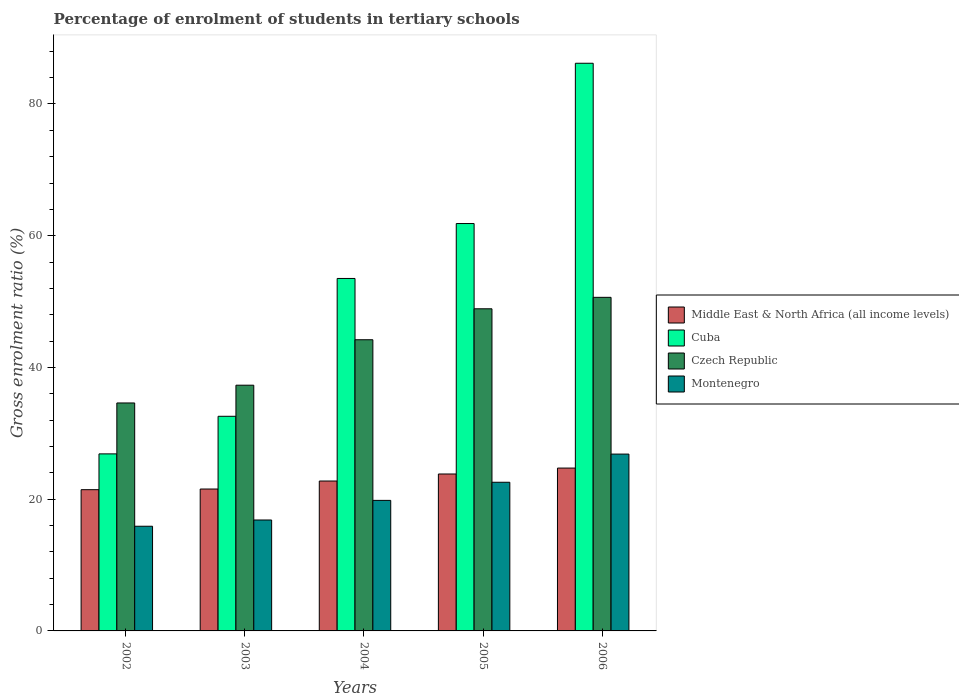How many different coloured bars are there?
Your answer should be very brief. 4. Are the number of bars per tick equal to the number of legend labels?
Provide a succinct answer. Yes. How many bars are there on the 2nd tick from the left?
Provide a succinct answer. 4. How many bars are there on the 2nd tick from the right?
Provide a succinct answer. 4. In how many cases, is the number of bars for a given year not equal to the number of legend labels?
Make the answer very short. 0. What is the percentage of students enrolled in tertiary schools in Montenegro in 2005?
Provide a succinct answer. 22.57. Across all years, what is the maximum percentage of students enrolled in tertiary schools in Czech Republic?
Provide a short and direct response. 50.65. Across all years, what is the minimum percentage of students enrolled in tertiary schools in Cuba?
Provide a short and direct response. 26.88. In which year was the percentage of students enrolled in tertiary schools in Middle East & North Africa (all income levels) maximum?
Offer a very short reply. 2006. What is the total percentage of students enrolled in tertiary schools in Middle East & North Africa (all income levels) in the graph?
Offer a very short reply. 114.3. What is the difference between the percentage of students enrolled in tertiary schools in Cuba in 2003 and that in 2005?
Your answer should be very brief. -29.26. What is the difference between the percentage of students enrolled in tertiary schools in Czech Republic in 2005 and the percentage of students enrolled in tertiary schools in Middle East & North Africa (all income levels) in 2006?
Your response must be concise. 24.18. What is the average percentage of students enrolled in tertiary schools in Czech Republic per year?
Give a very brief answer. 43.14. In the year 2002, what is the difference between the percentage of students enrolled in tertiary schools in Cuba and percentage of students enrolled in tertiary schools in Montenegro?
Offer a terse response. 10.98. In how many years, is the percentage of students enrolled in tertiary schools in Montenegro greater than 76 %?
Offer a very short reply. 0. What is the ratio of the percentage of students enrolled in tertiary schools in Middle East & North Africa (all income levels) in 2002 to that in 2006?
Offer a terse response. 0.87. What is the difference between the highest and the second highest percentage of students enrolled in tertiary schools in Czech Republic?
Give a very brief answer. 1.74. What is the difference between the highest and the lowest percentage of students enrolled in tertiary schools in Cuba?
Your answer should be compact. 59.31. What does the 1st bar from the left in 2006 represents?
Make the answer very short. Middle East & North Africa (all income levels). What does the 4th bar from the right in 2004 represents?
Make the answer very short. Middle East & North Africa (all income levels). How many bars are there?
Give a very brief answer. 20. How many years are there in the graph?
Give a very brief answer. 5. Are the values on the major ticks of Y-axis written in scientific E-notation?
Provide a short and direct response. No. Does the graph contain any zero values?
Give a very brief answer. No. Does the graph contain grids?
Keep it short and to the point. No. How are the legend labels stacked?
Offer a very short reply. Vertical. What is the title of the graph?
Make the answer very short. Percentage of enrolment of students in tertiary schools. What is the Gross enrolment ratio (%) in Middle East & North Africa (all income levels) in 2002?
Your answer should be very brief. 21.44. What is the Gross enrolment ratio (%) of Cuba in 2002?
Make the answer very short. 26.88. What is the Gross enrolment ratio (%) in Czech Republic in 2002?
Your answer should be very brief. 34.61. What is the Gross enrolment ratio (%) in Montenegro in 2002?
Offer a very short reply. 15.89. What is the Gross enrolment ratio (%) in Middle East & North Africa (all income levels) in 2003?
Offer a terse response. 21.54. What is the Gross enrolment ratio (%) in Cuba in 2003?
Provide a succinct answer. 32.59. What is the Gross enrolment ratio (%) of Czech Republic in 2003?
Provide a short and direct response. 37.31. What is the Gross enrolment ratio (%) in Montenegro in 2003?
Your answer should be very brief. 16.84. What is the Gross enrolment ratio (%) of Middle East & North Africa (all income levels) in 2004?
Provide a succinct answer. 22.76. What is the Gross enrolment ratio (%) of Cuba in 2004?
Give a very brief answer. 53.51. What is the Gross enrolment ratio (%) of Czech Republic in 2004?
Offer a terse response. 44.21. What is the Gross enrolment ratio (%) in Montenegro in 2004?
Your answer should be very brief. 19.82. What is the Gross enrolment ratio (%) in Middle East & North Africa (all income levels) in 2005?
Give a very brief answer. 23.83. What is the Gross enrolment ratio (%) of Cuba in 2005?
Your response must be concise. 61.85. What is the Gross enrolment ratio (%) in Czech Republic in 2005?
Provide a short and direct response. 48.91. What is the Gross enrolment ratio (%) of Montenegro in 2005?
Your response must be concise. 22.57. What is the Gross enrolment ratio (%) of Middle East & North Africa (all income levels) in 2006?
Offer a very short reply. 24.73. What is the Gross enrolment ratio (%) of Cuba in 2006?
Offer a very short reply. 86.19. What is the Gross enrolment ratio (%) in Czech Republic in 2006?
Offer a terse response. 50.65. What is the Gross enrolment ratio (%) in Montenegro in 2006?
Keep it short and to the point. 26.85. Across all years, what is the maximum Gross enrolment ratio (%) in Middle East & North Africa (all income levels)?
Your answer should be very brief. 24.73. Across all years, what is the maximum Gross enrolment ratio (%) in Cuba?
Your answer should be very brief. 86.19. Across all years, what is the maximum Gross enrolment ratio (%) in Czech Republic?
Ensure brevity in your answer.  50.65. Across all years, what is the maximum Gross enrolment ratio (%) in Montenegro?
Provide a short and direct response. 26.85. Across all years, what is the minimum Gross enrolment ratio (%) of Middle East & North Africa (all income levels)?
Your answer should be compact. 21.44. Across all years, what is the minimum Gross enrolment ratio (%) in Cuba?
Your answer should be compact. 26.88. Across all years, what is the minimum Gross enrolment ratio (%) in Czech Republic?
Your answer should be compact. 34.61. Across all years, what is the minimum Gross enrolment ratio (%) in Montenegro?
Offer a terse response. 15.89. What is the total Gross enrolment ratio (%) in Middle East & North Africa (all income levels) in the graph?
Offer a very short reply. 114.3. What is the total Gross enrolment ratio (%) of Cuba in the graph?
Your response must be concise. 261.01. What is the total Gross enrolment ratio (%) of Czech Republic in the graph?
Give a very brief answer. 215.68. What is the total Gross enrolment ratio (%) in Montenegro in the graph?
Your response must be concise. 101.97. What is the difference between the Gross enrolment ratio (%) of Middle East & North Africa (all income levels) in 2002 and that in 2003?
Your answer should be very brief. -0.1. What is the difference between the Gross enrolment ratio (%) in Cuba in 2002 and that in 2003?
Provide a short and direct response. -5.71. What is the difference between the Gross enrolment ratio (%) of Czech Republic in 2002 and that in 2003?
Your answer should be compact. -2.7. What is the difference between the Gross enrolment ratio (%) in Montenegro in 2002 and that in 2003?
Make the answer very short. -0.95. What is the difference between the Gross enrolment ratio (%) of Middle East & North Africa (all income levels) in 2002 and that in 2004?
Provide a short and direct response. -1.31. What is the difference between the Gross enrolment ratio (%) of Cuba in 2002 and that in 2004?
Offer a terse response. -26.63. What is the difference between the Gross enrolment ratio (%) of Czech Republic in 2002 and that in 2004?
Offer a terse response. -9.6. What is the difference between the Gross enrolment ratio (%) in Montenegro in 2002 and that in 2004?
Your response must be concise. -3.92. What is the difference between the Gross enrolment ratio (%) of Middle East & North Africa (all income levels) in 2002 and that in 2005?
Keep it short and to the point. -2.38. What is the difference between the Gross enrolment ratio (%) in Cuba in 2002 and that in 2005?
Make the answer very short. -34.97. What is the difference between the Gross enrolment ratio (%) of Czech Republic in 2002 and that in 2005?
Your answer should be very brief. -14.3. What is the difference between the Gross enrolment ratio (%) of Montenegro in 2002 and that in 2005?
Your response must be concise. -6.68. What is the difference between the Gross enrolment ratio (%) of Middle East & North Africa (all income levels) in 2002 and that in 2006?
Keep it short and to the point. -3.28. What is the difference between the Gross enrolment ratio (%) in Cuba in 2002 and that in 2006?
Your response must be concise. -59.31. What is the difference between the Gross enrolment ratio (%) in Czech Republic in 2002 and that in 2006?
Ensure brevity in your answer.  -16.04. What is the difference between the Gross enrolment ratio (%) of Montenegro in 2002 and that in 2006?
Your response must be concise. -10.95. What is the difference between the Gross enrolment ratio (%) in Middle East & North Africa (all income levels) in 2003 and that in 2004?
Your response must be concise. -1.21. What is the difference between the Gross enrolment ratio (%) of Cuba in 2003 and that in 2004?
Offer a terse response. -20.93. What is the difference between the Gross enrolment ratio (%) in Czech Republic in 2003 and that in 2004?
Offer a terse response. -6.9. What is the difference between the Gross enrolment ratio (%) in Montenegro in 2003 and that in 2004?
Your answer should be compact. -2.98. What is the difference between the Gross enrolment ratio (%) in Middle East & North Africa (all income levels) in 2003 and that in 2005?
Ensure brevity in your answer.  -2.28. What is the difference between the Gross enrolment ratio (%) in Cuba in 2003 and that in 2005?
Your response must be concise. -29.26. What is the difference between the Gross enrolment ratio (%) of Czech Republic in 2003 and that in 2005?
Your answer should be compact. -11.6. What is the difference between the Gross enrolment ratio (%) in Montenegro in 2003 and that in 2005?
Ensure brevity in your answer.  -5.73. What is the difference between the Gross enrolment ratio (%) in Middle East & North Africa (all income levels) in 2003 and that in 2006?
Your response must be concise. -3.18. What is the difference between the Gross enrolment ratio (%) in Cuba in 2003 and that in 2006?
Offer a very short reply. -53.6. What is the difference between the Gross enrolment ratio (%) in Czech Republic in 2003 and that in 2006?
Give a very brief answer. -13.34. What is the difference between the Gross enrolment ratio (%) of Montenegro in 2003 and that in 2006?
Offer a terse response. -10.01. What is the difference between the Gross enrolment ratio (%) in Middle East & North Africa (all income levels) in 2004 and that in 2005?
Your response must be concise. -1.07. What is the difference between the Gross enrolment ratio (%) of Cuba in 2004 and that in 2005?
Your response must be concise. -8.34. What is the difference between the Gross enrolment ratio (%) of Czech Republic in 2004 and that in 2005?
Offer a terse response. -4.7. What is the difference between the Gross enrolment ratio (%) of Montenegro in 2004 and that in 2005?
Offer a very short reply. -2.75. What is the difference between the Gross enrolment ratio (%) of Middle East & North Africa (all income levels) in 2004 and that in 2006?
Your answer should be very brief. -1.97. What is the difference between the Gross enrolment ratio (%) in Cuba in 2004 and that in 2006?
Ensure brevity in your answer.  -32.67. What is the difference between the Gross enrolment ratio (%) in Czech Republic in 2004 and that in 2006?
Keep it short and to the point. -6.44. What is the difference between the Gross enrolment ratio (%) in Montenegro in 2004 and that in 2006?
Keep it short and to the point. -7.03. What is the difference between the Gross enrolment ratio (%) of Middle East & North Africa (all income levels) in 2005 and that in 2006?
Give a very brief answer. -0.9. What is the difference between the Gross enrolment ratio (%) of Cuba in 2005 and that in 2006?
Provide a succinct answer. -24.33. What is the difference between the Gross enrolment ratio (%) of Czech Republic in 2005 and that in 2006?
Your answer should be very brief. -1.74. What is the difference between the Gross enrolment ratio (%) in Montenegro in 2005 and that in 2006?
Your answer should be compact. -4.28. What is the difference between the Gross enrolment ratio (%) in Middle East & North Africa (all income levels) in 2002 and the Gross enrolment ratio (%) in Cuba in 2003?
Offer a terse response. -11.14. What is the difference between the Gross enrolment ratio (%) in Middle East & North Africa (all income levels) in 2002 and the Gross enrolment ratio (%) in Czech Republic in 2003?
Offer a very short reply. -15.86. What is the difference between the Gross enrolment ratio (%) in Middle East & North Africa (all income levels) in 2002 and the Gross enrolment ratio (%) in Montenegro in 2003?
Your response must be concise. 4.6. What is the difference between the Gross enrolment ratio (%) of Cuba in 2002 and the Gross enrolment ratio (%) of Czech Republic in 2003?
Ensure brevity in your answer.  -10.43. What is the difference between the Gross enrolment ratio (%) in Cuba in 2002 and the Gross enrolment ratio (%) in Montenegro in 2003?
Keep it short and to the point. 10.04. What is the difference between the Gross enrolment ratio (%) in Czech Republic in 2002 and the Gross enrolment ratio (%) in Montenegro in 2003?
Your answer should be compact. 17.77. What is the difference between the Gross enrolment ratio (%) of Middle East & North Africa (all income levels) in 2002 and the Gross enrolment ratio (%) of Cuba in 2004?
Provide a succinct answer. -32.07. What is the difference between the Gross enrolment ratio (%) of Middle East & North Africa (all income levels) in 2002 and the Gross enrolment ratio (%) of Czech Republic in 2004?
Your response must be concise. -22.76. What is the difference between the Gross enrolment ratio (%) in Middle East & North Africa (all income levels) in 2002 and the Gross enrolment ratio (%) in Montenegro in 2004?
Your answer should be very brief. 1.62. What is the difference between the Gross enrolment ratio (%) of Cuba in 2002 and the Gross enrolment ratio (%) of Czech Republic in 2004?
Offer a very short reply. -17.33. What is the difference between the Gross enrolment ratio (%) of Cuba in 2002 and the Gross enrolment ratio (%) of Montenegro in 2004?
Make the answer very short. 7.06. What is the difference between the Gross enrolment ratio (%) of Czech Republic in 2002 and the Gross enrolment ratio (%) of Montenegro in 2004?
Offer a very short reply. 14.79. What is the difference between the Gross enrolment ratio (%) of Middle East & North Africa (all income levels) in 2002 and the Gross enrolment ratio (%) of Cuba in 2005?
Your answer should be compact. -40.41. What is the difference between the Gross enrolment ratio (%) in Middle East & North Africa (all income levels) in 2002 and the Gross enrolment ratio (%) in Czech Republic in 2005?
Make the answer very short. -27.46. What is the difference between the Gross enrolment ratio (%) of Middle East & North Africa (all income levels) in 2002 and the Gross enrolment ratio (%) of Montenegro in 2005?
Provide a short and direct response. -1.13. What is the difference between the Gross enrolment ratio (%) in Cuba in 2002 and the Gross enrolment ratio (%) in Czech Republic in 2005?
Ensure brevity in your answer.  -22.03. What is the difference between the Gross enrolment ratio (%) in Cuba in 2002 and the Gross enrolment ratio (%) in Montenegro in 2005?
Provide a short and direct response. 4.31. What is the difference between the Gross enrolment ratio (%) in Czech Republic in 2002 and the Gross enrolment ratio (%) in Montenegro in 2005?
Your answer should be very brief. 12.04. What is the difference between the Gross enrolment ratio (%) of Middle East & North Africa (all income levels) in 2002 and the Gross enrolment ratio (%) of Cuba in 2006?
Keep it short and to the point. -64.74. What is the difference between the Gross enrolment ratio (%) of Middle East & North Africa (all income levels) in 2002 and the Gross enrolment ratio (%) of Czech Republic in 2006?
Provide a short and direct response. -29.2. What is the difference between the Gross enrolment ratio (%) in Middle East & North Africa (all income levels) in 2002 and the Gross enrolment ratio (%) in Montenegro in 2006?
Ensure brevity in your answer.  -5.4. What is the difference between the Gross enrolment ratio (%) in Cuba in 2002 and the Gross enrolment ratio (%) in Czech Republic in 2006?
Make the answer very short. -23.77. What is the difference between the Gross enrolment ratio (%) of Cuba in 2002 and the Gross enrolment ratio (%) of Montenegro in 2006?
Your answer should be compact. 0.03. What is the difference between the Gross enrolment ratio (%) of Czech Republic in 2002 and the Gross enrolment ratio (%) of Montenegro in 2006?
Make the answer very short. 7.76. What is the difference between the Gross enrolment ratio (%) in Middle East & North Africa (all income levels) in 2003 and the Gross enrolment ratio (%) in Cuba in 2004?
Your answer should be compact. -31.97. What is the difference between the Gross enrolment ratio (%) of Middle East & North Africa (all income levels) in 2003 and the Gross enrolment ratio (%) of Czech Republic in 2004?
Your response must be concise. -22.66. What is the difference between the Gross enrolment ratio (%) of Middle East & North Africa (all income levels) in 2003 and the Gross enrolment ratio (%) of Montenegro in 2004?
Your response must be concise. 1.73. What is the difference between the Gross enrolment ratio (%) in Cuba in 2003 and the Gross enrolment ratio (%) in Czech Republic in 2004?
Give a very brief answer. -11.62. What is the difference between the Gross enrolment ratio (%) of Cuba in 2003 and the Gross enrolment ratio (%) of Montenegro in 2004?
Your answer should be compact. 12.77. What is the difference between the Gross enrolment ratio (%) in Czech Republic in 2003 and the Gross enrolment ratio (%) in Montenegro in 2004?
Offer a terse response. 17.49. What is the difference between the Gross enrolment ratio (%) of Middle East & North Africa (all income levels) in 2003 and the Gross enrolment ratio (%) of Cuba in 2005?
Your response must be concise. -40.31. What is the difference between the Gross enrolment ratio (%) in Middle East & North Africa (all income levels) in 2003 and the Gross enrolment ratio (%) in Czech Republic in 2005?
Your answer should be compact. -27.36. What is the difference between the Gross enrolment ratio (%) in Middle East & North Africa (all income levels) in 2003 and the Gross enrolment ratio (%) in Montenegro in 2005?
Provide a short and direct response. -1.03. What is the difference between the Gross enrolment ratio (%) in Cuba in 2003 and the Gross enrolment ratio (%) in Czech Republic in 2005?
Make the answer very short. -16.32. What is the difference between the Gross enrolment ratio (%) of Cuba in 2003 and the Gross enrolment ratio (%) of Montenegro in 2005?
Provide a short and direct response. 10.02. What is the difference between the Gross enrolment ratio (%) of Czech Republic in 2003 and the Gross enrolment ratio (%) of Montenegro in 2005?
Provide a succinct answer. 14.74. What is the difference between the Gross enrolment ratio (%) of Middle East & North Africa (all income levels) in 2003 and the Gross enrolment ratio (%) of Cuba in 2006?
Your answer should be very brief. -64.64. What is the difference between the Gross enrolment ratio (%) in Middle East & North Africa (all income levels) in 2003 and the Gross enrolment ratio (%) in Czech Republic in 2006?
Your answer should be compact. -29.1. What is the difference between the Gross enrolment ratio (%) of Middle East & North Africa (all income levels) in 2003 and the Gross enrolment ratio (%) of Montenegro in 2006?
Provide a succinct answer. -5.3. What is the difference between the Gross enrolment ratio (%) in Cuba in 2003 and the Gross enrolment ratio (%) in Czech Republic in 2006?
Offer a terse response. -18.06. What is the difference between the Gross enrolment ratio (%) in Cuba in 2003 and the Gross enrolment ratio (%) in Montenegro in 2006?
Provide a short and direct response. 5.74. What is the difference between the Gross enrolment ratio (%) in Czech Republic in 2003 and the Gross enrolment ratio (%) in Montenegro in 2006?
Ensure brevity in your answer.  10.46. What is the difference between the Gross enrolment ratio (%) of Middle East & North Africa (all income levels) in 2004 and the Gross enrolment ratio (%) of Cuba in 2005?
Provide a succinct answer. -39.09. What is the difference between the Gross enrolment ratio (%) of Middle East & North Africa (all income levels) in 2004 and the Gross enrolment ratio (%) of Czech Republic in 2005?
Provide a short and direct response. -26.15. What is the difference between the Gross enrolment ratio (%) in Middle East & North Africa (all income levels) in 2004 and the Gross enrolment ratio (%) in Montenegro in 2005?
Ensure brevity in your answer.  0.19. What is the difference between the Gross enrolment ratio (%) of Cuba in 2004 and the Gross enrolment ratio (%) of Czech Republic in 2005?
Provide a short and direct response. 4.6. What is the difference between the Gross enrolment ratio (%) in Cuba in 2004 and the Gross enrolment ratio (%) in Montenegro in 2005?
Your response must be concise. 30.94. What is the difference between the Gross enrolment ratio (%) of Czech Republic in 2004 and the Gross enrolment ratio (%) of Montenegro in 2005?
Give a very brief answer. 21.64. What is the difference between the Gross enrolment ratio (%) of Middle East & North Africa (all income levels) in 2004 and the Gross enrolment ratio (%) of Cuba in 2006?
Keep it short and to the point. -63.43. What is the difference between the Gross enrolment ratio (%) in Middle East & North Africa (all income levels) in 2004 and the Gross enrolment ratio (%) in Czech Republic in 2006?
Your response must be concise. -27.89. What is the difference between the Gross enrolment ratio (%) in Middle East & North Africa (all income levels) in 2004 and the Gross enrolment ratio (%) in Montenegro in 2006?
Offer a very short reply. -4.09. What is the difference between the Gross enrolment ratio (%) of Cuba in 2004 and the Gross enrolment ratio (%) of Czech Republic in 2006?
Offer a terse response. 2.86. What is the difference between the Gross enrolment ratio (%) of Cuba in 2004 and the Gross enrolment ratio (%) of Montenegro in 2006?
Offer a very short reply. 26.66. What is the difference between the Gross enrolment ratio (%) of Czech Republic in 2004 and the Gross enrolment ratio (%) of Montenegro in 2006?
Make the answer very short. 17.36. What is the difference between the Gross enrolment ratio (%) in Middle East & North Africa (all income levels) in 2005 and the Gross enrolment ratio (%) in Cuba in 2006?
Your response must be concise. -62.36. What is the difference between the Gross enrolment ratio (%) in Middle East & North Africa (all income levels) in 2005 and the Gross enrolment ratio (%) in Czech Republic in 2006?
Your answer should be very brief. -26.82. What is the difference between the Gross enrolment ratio (%) in Middle East & North Africa (all income levels) in 2005 and the Gross enrolment ratio (%) in Montenegro in 2006?
Keep it short and to the point. -3.02. What is the difference between the Gross enrolment ratio (%) of Cuba in 2005 and the Gross enrolment ratio (%) of Czech Republic in 2006?
Keep it short and to the point. 11.2. What is the difference between the Gross enrolment ratio (%) of Cuba in 2005 and the Gross enrolment ratio (%) of Montenegro in 2006?
Provide a succinct answer. 35. What is the difference between the Gross enrolment ratio (%) in Czech Republic in 2005 and the Gross enrolment ratio (%) in Montenegro in 2006?
Provide a short and direct response. 22.06. What is the average Gross enrolment ratio (%) in Middle East & North Africa (all income levels) per year?
Your response must be concise. 22.86. What is the average Gross enrolment ratio (%) in Cuba per year?
Offer a very short reply. 52.2. What is the average Gross enrolment ratio (%) of Czech Republic per year?
Offer a very short reply. 43.14. What is the average Gross enrolment ratio (%) of Montenegro per year?
Your answer should be very brief. 20.39. In the year 2002, what is the difference between the Gross enrolment ratio (%) of Middle East & North Africa (all income levels) and Gross enrolment ratio (%) of Cuba?
Give a very brief answer. -5.43. In the year 2002, what is the difference between the Gross enrolment ratio (%) in Middle East & North Africa (all income levels) and Gross enrolment ratio (%) in Czech Republic?
Keep it short and to the point. -13.17. In the year 2002, what is the difference between the Gross enrolment ratio (%) of Middle East & North Africa (all income levels) and Gross enrolment ratio (%) of Montenegro?
Ensure brevity in your answer.  5.55. In the year 2002, what is the difference between the Gross enrolment ratio (%) in Cuba and Gross enrolment ratio (%) in Czech Republic?
Offer a very short reply. -7.73. In the year 2002, what is the difference between the Gross enrolment ratio (%) of Cuba and Gross enrolment ratio (%) of Montenegro?
Your answer should be very brief. 10.98. In the year 2002, what is the difference between the Gross enrolment ratio (%) of Czech Republic and Gross enrolment ratio (%) of Montenegro?
Your answer should be very brief. 18.72. In the year 2003, what is the difference between the Gross enrolment ratio (%) of Middle East & North Africa (all income levels) and Gross enrolment ratio (%) of Cuba?
Your response must be concise. -11.04. In the year 2003, what is the difference between the Gross enrolment ratio (%) of Middle East & North Africa (all income levels) and Gross enrolment ratio (%) of Czech Republic?
Offer a very short reply. -15.76. In the year 2003, what is the difference between the Gross enrolment ratio (%) of Middle East & North Africa (all income levels) and Gross enrolment ratio (%) of Montenegro?
Ensure brevity in your answer.  4.7. In the year 2003, what is the difference between the Gross enrolment ratio (%) of Cuba and Gross enrolment ratio (%) of Czech Republic?
Give a very brief answer. -4.72. In the year 2003, what is the difference between the Gross enrolment ratio (%) in Cuba and Gross enrolment ratio (%) in Montenegro?
Ensure brevity in your answer.  15.75. In the year 2003, what is the difference between the Gross enrolment ratio (%) in Czech Republic and Gross enrolment ratio (%) in Montenegro?
Provide a short and direct response. 20.47. In the year 2004, what is the difference between the Gross enrolment ratio (%) of Middle East & North Africa (all income levels) and Gross enrolment ratio (%) of Cuba?
Your response must be concise. -30.75. In the year 2004, what is the difference between the Gross enrolment ratio (%) of Middle East & North Africa (all income levels) and Gross enrolment ratio (%) of Czech Republic?
Your response must be concise. -21.45. In the year 2004, what is the difference between the Gross enrolment ratio (%) of Middle East & North Africa (all income levels) and Gross enrolment ratio (%) of Montenegro?
Make the answer very short. 2.94. In the year 2004, what is the difference between the Gross enrolment ratio (%) in Cuba and Gross enrolment ratio (%) in Czech Republic?
Offer a terse response. 9.3. In the year 2004, what is the difference between the Gross enrolment ratio (%) in Cuba and Gross enrolment ratio (%) in Montenegro?
Your answer should be very brief. 33.69. In the year 2004, what is the difference between the Gross enrolment ratio (%) in Czech Republic and Gross enrolment ratio (%) in Montenegro?
Keep it short and to the point. 24.39. In the year 2005, what is the difference between the Gross enrolment ratio (%) in Middle East & North Africa (all income levels) and Gross enrolment ratio (%) in Cuba?
Provide a succinct answer. -38.03. In the year 2005, what is the difference between the Gross enrolment ratio (%) in Middle East & North Africa (all income levels) and Gross enrolment ratio (%) in Czech Republic?
Give a very brief answer. -25.08. In the year 2005, what is the difference between the Gross enrolment ratio (%) of Middle East & North Africa (all income levels) and Gross enrolment ratio (%) of Montenegro?
Ensure brevity in your answer.  1.26. In the year 2005, what is the difference between the Gross enrolment ratio (%) of Cuba and Gross enrolment ratio (%) of Czech Republic?
Keep it short and to the point. 12.94. In the year 2005, what is the difference between the Gross enrolment ratio (%) of Cuba and Gross enrolment ratio (%) of Montenegro?
Make the answer very short. 39.28. In the year 2005, what is the difference between the Gross enrolment ratio (%) of Czech Republic and Gross enrolment ratio (%) of Montenegro?
Give a very brief answer. 26.34. In the year 2006, what is the difference between the Gross enrolment ratio (%) in Middle East & North Africa (all income levels) and Gross enrolment ratio (%) in Cuba?
Make the answer very short. -61.46. In the year 2006, what is the difference between the Gross enrolment ratio (%) in Middle East & North Africa (all income levels) and Gross enrolment ratio (%) in Czech Republic?
Ensure brevity in your answer.  -25.92. In the year 2006, what is the difference between the Gross enrolment ratio (%) in Middle East & North Africa (all income levels) and Gross enrolment ratio (%) in Montenegro?
Offer a very short reply. -2.12. In the year 2006, what is the difference between the Gross enrolment ratio (%) in Cuba and Gross enrolment ratio (%) in Czech Republic?
Make the answer very short. 35.54. In the year 2006, what is the difference between the Gross enrolment ratio (%) of Cuba and Gross enrolment ratio (%) of Montenegro?
Provide a succinct answer. 59.34. In the year 2006, what is the difference between the Gross enrolment ratio (%) in Czech Republic and Gross enrolment ratio (%) in Montenegro?
Make the answer very short. 23.8. What is the ratio of the Gross enrolment ratio (%) of Cuba in 2002 to that in 2003?
Offer a very short reply. 0.82. What is the ratio of the Gross enrolment ratio (%) of Czech Republic in 2002 to that in 2003?
Provide a succinct answer. 0.93. What is the ratio of the Gross enrolment ratio (%) in Montenegro in 2002 to that in 2003?
Your answer should be compact. 0.94. What is the ratio of the Gross enrolment ratio (%) of Middle East & North Africa (all income levels) in 2002 to that in 2004?
Give a very brief answer. 0.94. What is the ratio of the Gross enrolment ratio (%) in Cuba in 2002 to that in 2004?
Keep it short and to the point. 0.5. What is the ratio of the Gross enrolment ratio (%) of Czech Republic in 2002 to that in 2004?
Give a very brief answer. 0.78. What is the ratio of the Gross enrolment ratio (%) in Montenegro in 2002 to that in 2004?
Keep it short and to the point. 0.8. What is the ratio of the Gross enrolment ratio (%) in Middle East & North Africa (all income levels) in 2002 to that in 2005?
Offer a terse response. 0.9. What is the ratio of the Gross enrolment ratio (%) in Cuba in 2002 to that in 2005?
Your response must be concise. 0.43. What is the ratio of the Gross enrolment ratio (%) of Czech Republic in 2002 to that in 2005?
Offer a very short reply. 0.71. What is the ratio of the Gross enrolment ratio (%) in Montenegro in 2002 to that in 2005?
Your answer should be very brief. 0.7. What is the ratio of the Gross enrolment ratio (%) in Middle East & North Africa (all income levels) in 2002 to that in 2006?
Give a very brief answer. 0.87. What is the ratio of the Gross enrolment ratio (%) in Cuba in 2002 to that in 2006?
Your answer should be compact. 0.31. What is the ratio of the Gross enrolment ratio (%) in Czech Republic in 2002 to that in 2006?
Keep it short and to the point. 0.68. What is the ratio of the Gross enrolment ratio (%) in Montenegro in 2002 to that in 2006?
Ensure brevity in your answer.  0.59. What is the ratio of the Gross enrolment ratio (%) in Middle East & North Africa (all income levels) in 2003 to that in 2004?
Make the answer very short. 0.95. What is the ratio of the Gross enrolment ratio (%) of Cuba in 2003 to that in 2004?
Give a very brief answer. 0.61. What is the ratio of the Gross enrolment ratio (%) in Czech Republic in 2003 to that in 2004?
Provide a short and direct response. 0.84. What is the ratio of the Gross enrolment ratio (%) in Montenegro in 2003 to that in 2004?
Offer a terse response. 0.85. What is the ratio of the Gross enrolment ratio (%) of Middle East & North Africa (all income levels) in 2003 to that in 2005?
Your answer should be compact. 0.9. What is the ratio of the Gross enrolment ratio (%) of Cuba in 2003 to that in 2005?
Ensure brevity in your answer.  0.53. What is the ratio of the Gross enrolment ratio (%) in Czech Republic in 2003 to that in 2005?
Your answer should be compact. 0.76. What is the ratio of the Gross enrolment ratio (%) of Montenegro in 2003 to that in 2005?
Your response must be concise. 0.75. What is the ratio of the Gross enrolment ratio (%) in Middle East & North Africa (all income levels) in 2003 to that in 2006?
Your answer should be very brief. 0.87. What is the ratio of the Gross enrolment ratio (%) of Cuba in 2003 to that in 2006?
Offer a terse response. 0.38. What is the ratio of the Gross enrolment ratio (%) of Czech Republic in 2003 to that in 2006?
Provide a succinct answer. 0.74. What is the ratio of the Gross enrolment ratio (%) of Montenegro in 2003 to that in 2006?
Offer a terse response. 0.63. What is the ratio of the Gross enrolment ratio (%) of Middle East & North Africa (all income levels) in 2004 to that in 2005?
Keep it short and to the point. 0.96. What is the ratio of the Gross enrolment ratio (%) of Cuba in 2004 to that in 2005?
Your response must be concise. 0.87. What is the ratio of the Gross enrolment ratio (%) of Czech Republic in 2004 to that in 2005?
Give a very brief answer. 0.9. What is the ratio of the Gross enrolment ratio (%) of Montenegro in 2004 to that in 2005?
Provide a succinct answer. 0.88. What is the ratio of the Gross enrolment ratio (%) of Middle East & North Africa (all income levels) in 2004 to that in 2006?
Your answer should be compact. 0.92. What is the ratio of the Gross enrolment ratio (%) of Cuba in 2004 to that in 2006?
Your answer should be very brief. 0.62. What is the ratio of the Gross enrolment ratio (%) of Czech Republic in 2004 to that in 2006?
Your answer should be very brief. 0.87. What is the ratio of the Gross enrolment ratio (%) of Montenegro in 2004 to that in 2006?
Your response must be concise. 0.74. What is the ratio of the Gross enrolment ratio (%) of Middle East & North Africa (all income levels) in 2005 to that in 2006?
Offer a very short reply. 0.96. What is the ratio of the Gross enrolment ratio (%) in Cuba in 2005 to that in 2006?
Give a very brief answer. 0.72. What is the ratio of the Gross enrolment ratio (%) of Czech Republic in 2005 to that in 2006?
Your answer should be very brief. 0.97. What is the ratio of the Gross enrolment ratio (%) in Montenegro in 2005 to that in 2006?
Your answer should be very brief. 0.84. What is the difference between the highest and the second highest Gross enrolment ratio (%) of Middle East & North Africa (all income levels)?
Provide a short and direct response. 0.9. What is the difference between the highest and the second highest Gross enrolment ratio (%) in Cuba?
Give a very brief answer. 24.33. What is the difference between the highest and the second highest Gross enrolment ratio (%) of Czech Republic?
Offer a very short reply. 1.74. What is the difference between the highest and the second highest Gross enrolment ratio (%) in Montenegro?
Make the answer very short. 4.28. What is the difference between the highest and the lowest Gross enrolment ratio (%) of Middle East & North Africa (all income levels)?
Your answer should be very brief. 3.28. What is the difference between the highest and the lowest Gross enrolment ratio (%) in Cuba?
Ensure brevity in your answer.  59.31. What is the difference between the highest and the lowest Gross enrolment ratio (%) of Czech Republic?
Give a very brief answer. 16.04. What is the difference between the highest and the lowest Gross enrolment ratio (%) of Montenegro?
Provide a short and direct response. 10.95. 